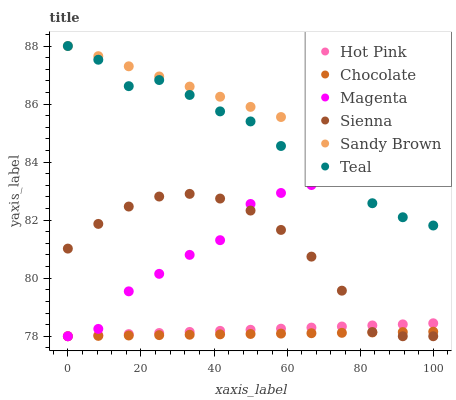Does Chocolate have the minimum area under the curve?
Answer yes or no. Yes. Does Sandy Brown have the maximum area under the curve?
Answer yes or no. Yes. Does Sienna have the minimum area under the curve?
Answer yes or no. No. Does Sienna have the maximum area under the curve?
Answer yes or no. No. Is Chocolate the smoothest?
Answer yes or no. Yes. Is Magenta the roughest?
Answer yes or no. Yes. Is Sienna the smoothest?
Answer yes or no. No. Is Sienna the roughest?
Answer yes or no. No. Does Hot Pink have the lowest value?
Answer yes or no. Yes. Does Teal have the lowest value?
Answer yes or no. No. Does Sandy Brown have the highest value?
Answer yes or no. Yes. Does Sienna have the highest value?
Answer yes or no. No. Is Chocolate less than Teal?
Answer yes or no. Yes. Is Teal greater than Chocolate?
Answer yes or no. Yes. Does Magenta intersect Hot Pink?
Answer yes or no. Yes. Is Magenta less than Hot Pink?
Answer yes or no. No. Is Magenta greater than Hot Pink?
Answer yes or no. No. Does Chocolate intersect Teal?
Answer yes or no. No. 